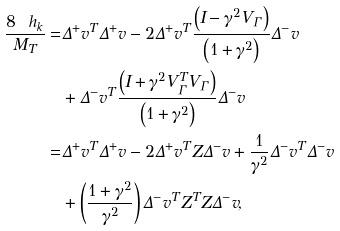Convert formula to latex. <formula><loc_0><loc_0><loc_500><loc_500>\frac { 8 \ h _ { k } } { M _ { T } } = & \Delta ^ { + } v ^ { T } \Delta ^ { + } v - 2 \Delta ^ { + } v ^ { T } \frac { \left ( I - \gamma ^ { 2 } V _ { \Gamma } \right ) } { \left ( 1 + \gamma ^ { 2 } \right ) } \Delta ^ { - } v \\ & + \Delta ^ { - } v ^ { T } \frac { \left ( I + \gamma ^ { 2 } V _ { \Gamma } ^ { T } V _ { \Gamma } \right ) } { \left ( 1 + \gamma ^ { 2 } \right ) } \Delta ^ { - } v \\ = & \Delta ^ { + } v ^ { T } \Delta ^ { + } v - 2 \Delta ^ { + } v ^ { T } Z \Delta ^ { - } v + \frac { 1 } { \gamma ^ { 2 } } \Delta ^ { - } v ^ { T } \Delta ^ { - } v \\ & + \left ( \frac { 1 + \gamma ^ { 2 } } { \gamma ^ { 2 } } \right ) \Delta ^ { - } v ^ { T } Z ^ { T } Z \Delta ^ { - } v ,</formula> 